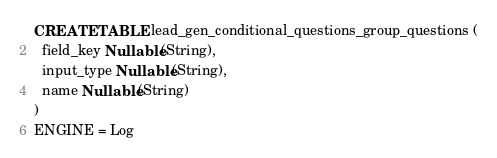<code> <loc_0><loc_0><loc_500><loc_500><_SQL_>CREATE TABLE lead_gen_conditional_questions_group_questions (
  field_key Nullable(String),
  input_type Nullable(String),
  name Nullable(String)
)
ENGINE = Log
</code> 